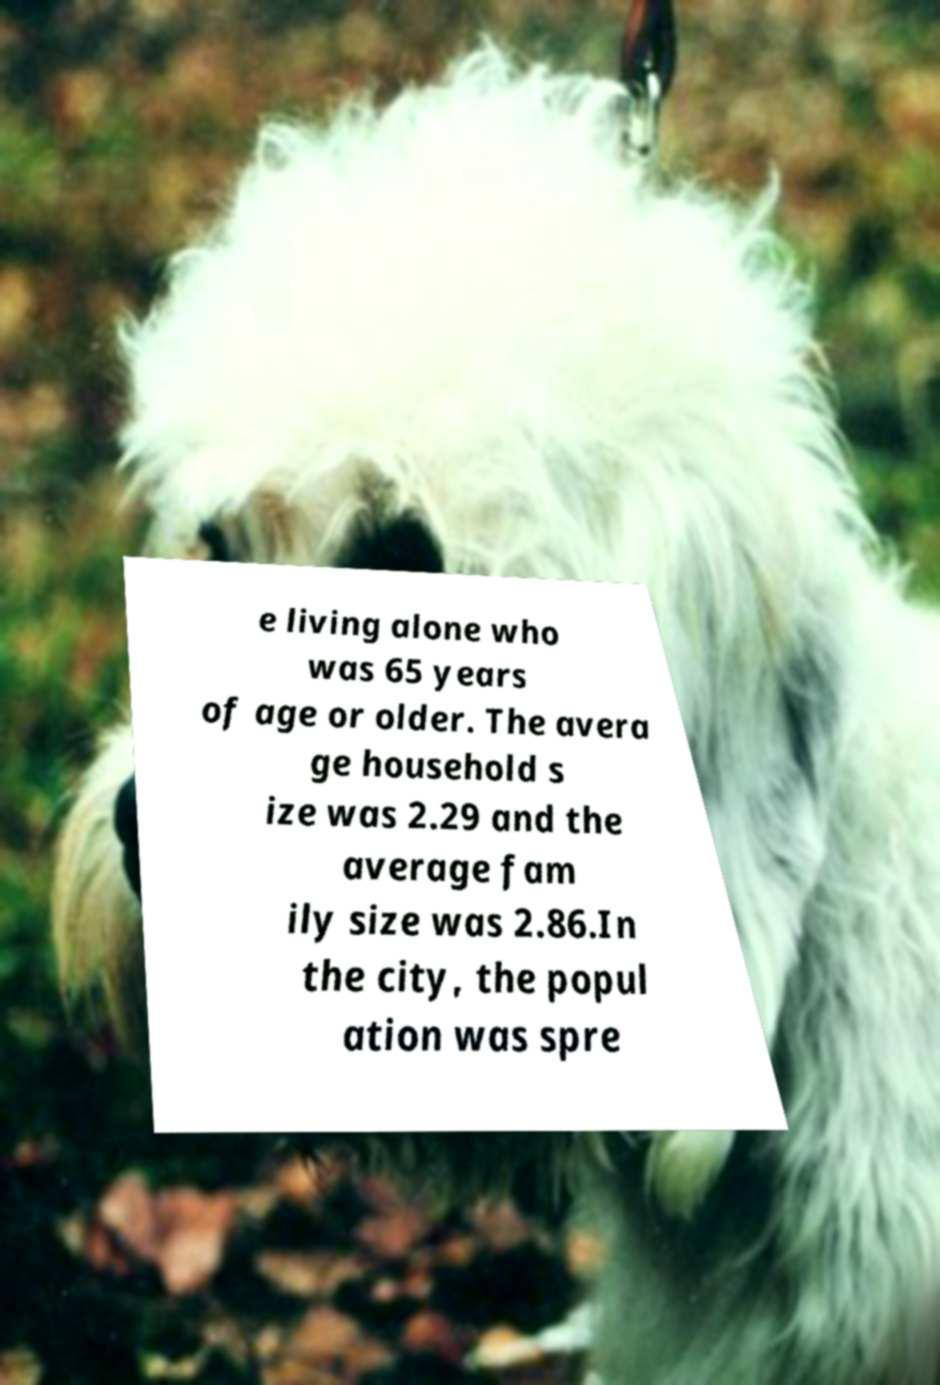Can you accurately transcribe the text from the provided image for me? e living alone who was 65 years of age or older. The avera ge household s ize was 2.29 and the average fam ily size was 2.86.In the city, the popul ation was spre 